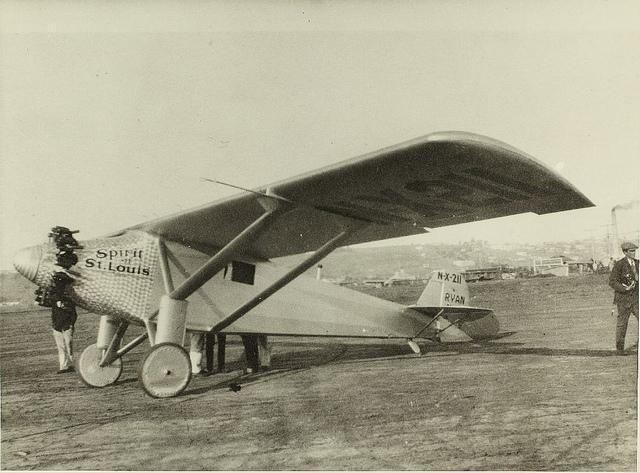How many engines are in the plane?
Give a very brief answer. 1. How many people are shown here?
Give a very brief answer. 2. How many people are there?
Give a very brief answer. 2. 